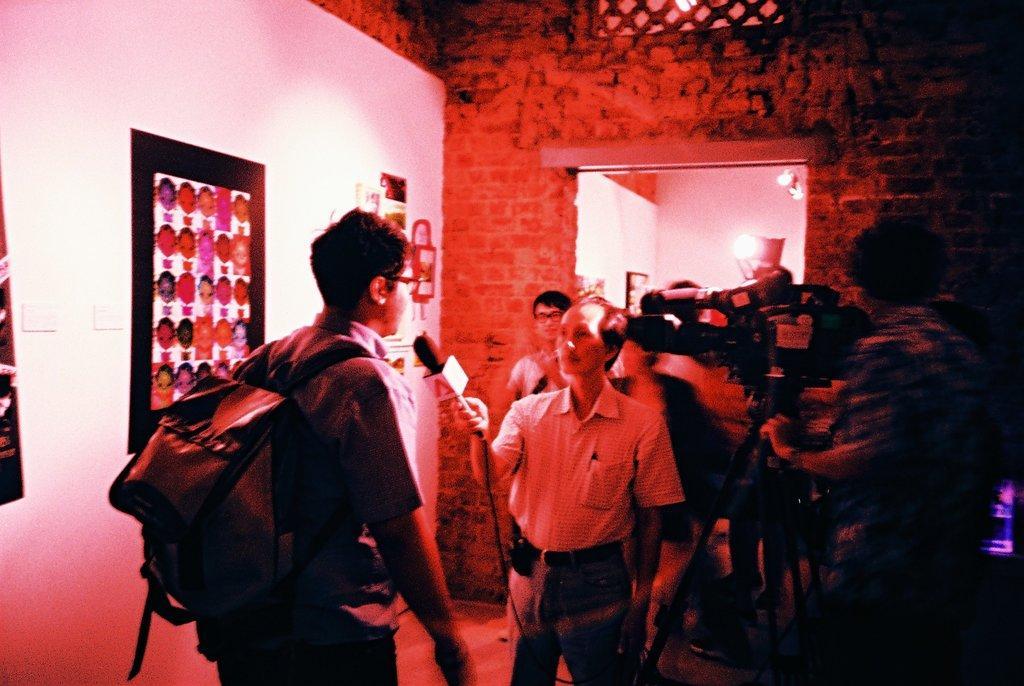Please provide a concise description of this image. In this image I can see a person standing wearing a bag, I can also see the other person holding a microphone. Background I can see a camera, a paper attached to the wall and I can see few lights. 